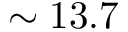Convert formula to latex. <formula><loc_0><loc_0><loc_500><loc_500>\sim 1 3 . 7</formula> 